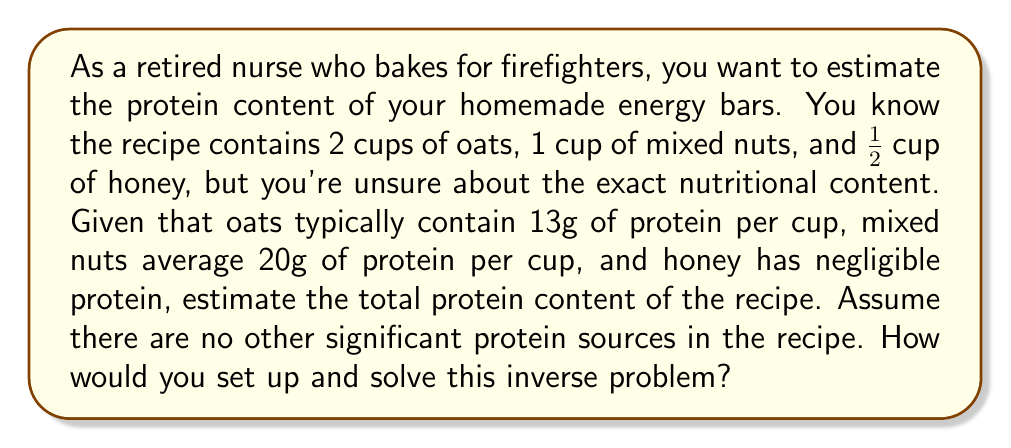What is the answer to this math problem? To solve this inverse problem, we need to:

1. Identify known information:
   - 2 cups of oats
   - 1 cup of mixed nuts
   - 1/2 cup of honey
   - Oats contain 13g of protein per cup
   - Mixed nuts contain 20g of protein per cup
   - Honey has negligible protein

2. Set up the equation:
   Let $x$ be the total protein content of the recipe.
   $$x = 2(13) + 1(20) + 0$$

3. Solve the equation:
   $$x = 26 + 20 + 0$$
   $$x = 46$$

The inverse problem is solved by using the known nutritional information of the ingredients to infer the total protein content of the recipe. This approach assumes that the protein content of each ingredient is additive and that there are no interactions between ingredients that would affect the overall protein content.
Answer: 46g of protein 